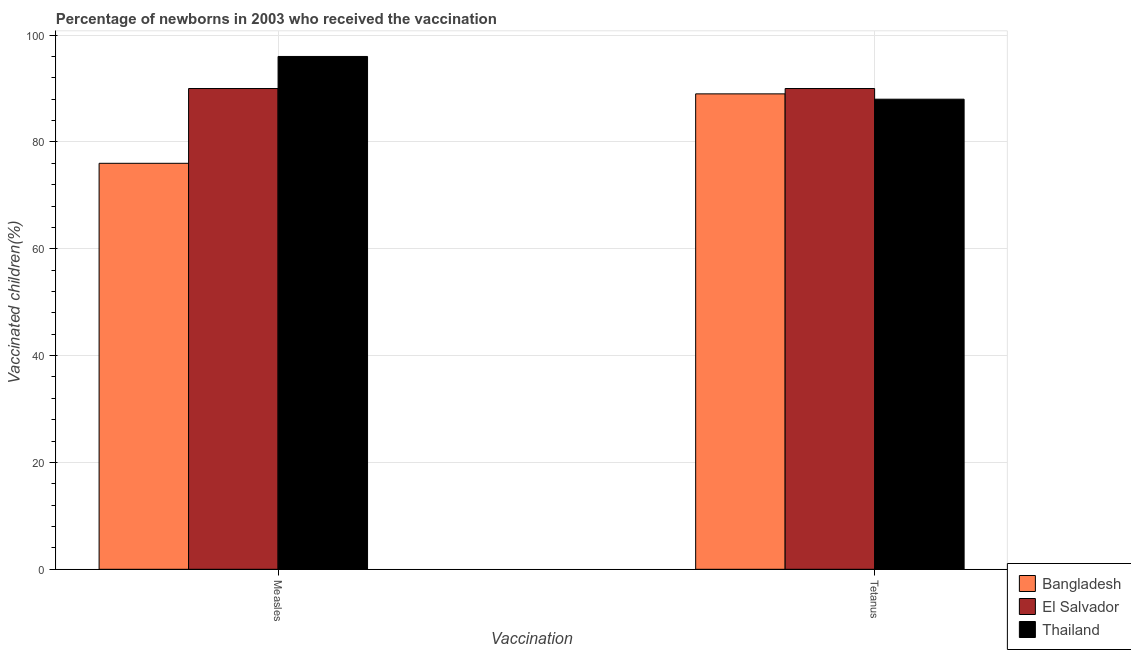How many different coloured bars are there?
Keep it short and to the point. 3. Are the number of bars on each tick of the X-axis equal?
Your answer should be very brief. Yes. How many bars are there on the 1st tick from the left?
Make the answer very short. 3. What is the label of the 2nd group of bars from the left?
Your response must be concise. Tetanus. What is the percentage of newborns who received vaccination for measles in Bangladesh?
Keep it short and to the point. 76. Across all countries, what is the maximum percentage of newborns who received vaccination for measles?
Make the answer very short. 96. Across all countries, what is the minimum percentage of newborns who received vaccination for tetanus?
Give a very brief answer. 88. In which country was the percentage of newborns who received vaccination for tetanus maximum?
Give a very brief answer. El Salvador. What is the total percentage of newborns who received vaccination for measles in the graph?
Make the answer very short. 262. What is the difference between the percentage of newborns who received vaccination for tetanus in Bangladesh and that in El Salvador?
Your answer should be very brief. -1. What is the difference between the percentage of newborns who received vaccination for measles in El Salvador and the percentage of newborns who received vaccination for tetanus in Thailand?
Your response must be concise. 2. What is the average percentage of newborns who received vaccination for measles per country?
Provide a succinct answer. 87.33. What is the difference between the percentage of newborns who received vaccination for measles and percentage of newborns who received vaccination for tetanus in Bangladesh?
Your response must be concise. -13. In how many countries, is the percentage of newborns who received vaccination for tetanus greater than 28 %?
Your response must be concise. 3. What is the ratio of the percentage of newborns who received vaccination for tetanus in Thailand to that in Bangladesh?
Your answer should be very brief. 0.99. Is the percentage of newborns who received vaccination for measles in Thailand less than that in Bangladesh?
Your response must be concise. No. What does the 2nd bar from the left in Measles represents?
Your answer should be compact. El Salvador. What does the 2nd bar from the right in Measles represents?
Provide a succinct answer. El Salvador. What is the difference between two consecutive major ticks on the Y-axis?
Ensure brevity in your answer.  20. Are the values on the major ticks of Y-axis written in scientific E-notation?
Provide a succinct answer. No. Does the graph contain any zero values?
Keep it short and to the point. No. Where does the legend appear in the graph?
Provide a short and direct response. Bottom right. How many legend labels are there?
Your answer should be compact. 3. How are the legend labels stacked?
Your answer should be very brief. Vertical. What is the title of the graph?
Provide a succinct answer. Percentage of newborns in 2003 who received the vaccination. Does "Poland" appear as one of the legend labels in the graph?
Offer a very short reply. No. What is the label or title of the X-axis?
Provide a succinct answer. Vaccination. What is the label or title of the Y-axis?
Your answer should be compact. Vaccinated children(%)
. What is the Vaccinated children(%)
 of Bangladesh in Measles?
Make the answer very short. 76. What is the Vaccinated children(%)
 in Thailand in Measles?
Your answer should be compact. 96. What is the Vaccinated children(%)
 of Bangladesh in Tetanus?
Make the answer very short. 89. What is the Vaccinated children(%)
 of El Salvador in Tetanus?
Ensure brevity in your answer.  90. Across all Vaccination, what is the maximum Vaccinated children(%)
 in Bangladesh?
Provide a short and direct response. 89. Across all Vaccination, what is the maximum Vaccinated children(%)
 of El Salvador?
Your answer should be compact. 90. Across all Vaccination, what is the maximum Vaccinated children(%)
 of Thailand?
Offer a very short reply. 96. Across all Vaccination, what is the minimum Vaccinated children(%)
 in El Salvador?
Keep it short and to the point. 90. What is the total Vaccinated children(%)
 of Bangladesh in the graph?
Your answer should be very brief. 165. What is the total Vaccinated children(%)
 of El Salvador in the graph?
Offer a very short reply. 180. What is the total Vaccinated children(%)
 in Thailand in the graph?
Your response must be concise. 184. What is the difference between the Vaccinated children(%)
 of Bangladesh in Measles and that in Tetanus?
Your answer should be compact. -13. What is the difference between the Vaccinated children(%)
 of Bangladesh in Measles and the Vaccinated children(%)
 of Thailand in Tetanus?
Provide a short and direct response. -12. What is the average Vaccinated children(%)
 in Bangladesh per Vaccination?
Your response must be concise. 82.5. What is the average Vaccinated children(%)
 in Thailand per Vaccination?
Your answer should be very brief. 92. What is the difference between the Vaccinated children(%)
 of Bangladesh and Vaccinated children(%)
 of El Salvador in Measles?
Give a very brief answer. -14. What is the difference between the Vaccinated children(%)
 of Bangladesh and Vaccinated children(%)
 of El Salvador in Tetanus?
Offer a terse response. -1. What is the difference between the Vaccinated children(%)
 in Bangladesh and Vaccinated children(%)
 in Thailand in Tetanus?
Give a very brief answer. 1. What is the difference between the Vaccinated children(%)
 of El Salvador and Vaccinated children(%)
 of Thailand in Tetanus?
Your answer should be compact. 2. What is the ratio of the Vaccinated children(%)
 in Bangladesh in Measles to that in Tetanus?
Your response must be concise. 0.85. What is the ratio of the Vaccinated children(%)
 of El Salvador in Measles to that in Tetanus?
Make the answer very short. 1. What is the difference between the highest and the second highest Vaccinated children(%)
 of El Salvador?
Keep it short and to the point. 0. What is the difference between the highest and the second highest Vaccinated children(%)
 in Thailand?
Offer a very short reply. 8. What is the difference between the highest and the lowest Vaccinated children(%)
 of El Salvador?
Your answer should be very brief. 0. What is the difference between the highest and the lowest Vaccinated children(%)
 in Thailand?
Offer a terse response. 8. 